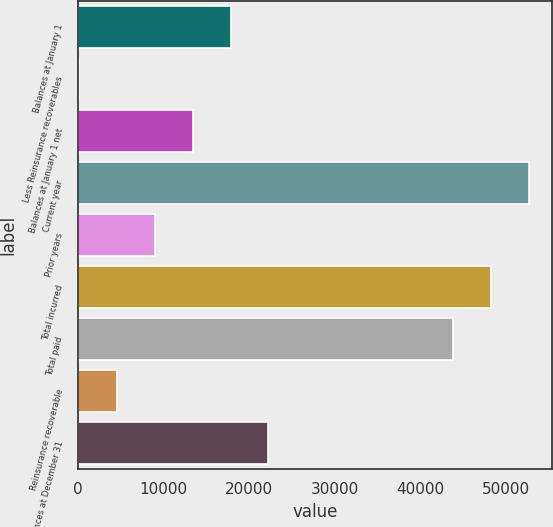Convert chart. <chart><loc_0><loc_0><loc_500><loc_500><bar_chart><fcel>Balances at January 1<fcel>Less Reinsurance recoverables<fcel>Balances at January 1 net<fcel>Current year<fcel>Prior years<fcel>Total incurred<fcel>Total paid<fcel>Reinsurance recoverable<fcel>Balances at December 31<nl><fcel>17805.6<fcel>78<fcel>13373.7<fcel>52706.8<fcel>8941.8<fcel>48274.9<fcel>43843<fcel>4509.9<fcel>22237.5<nl></chart> 